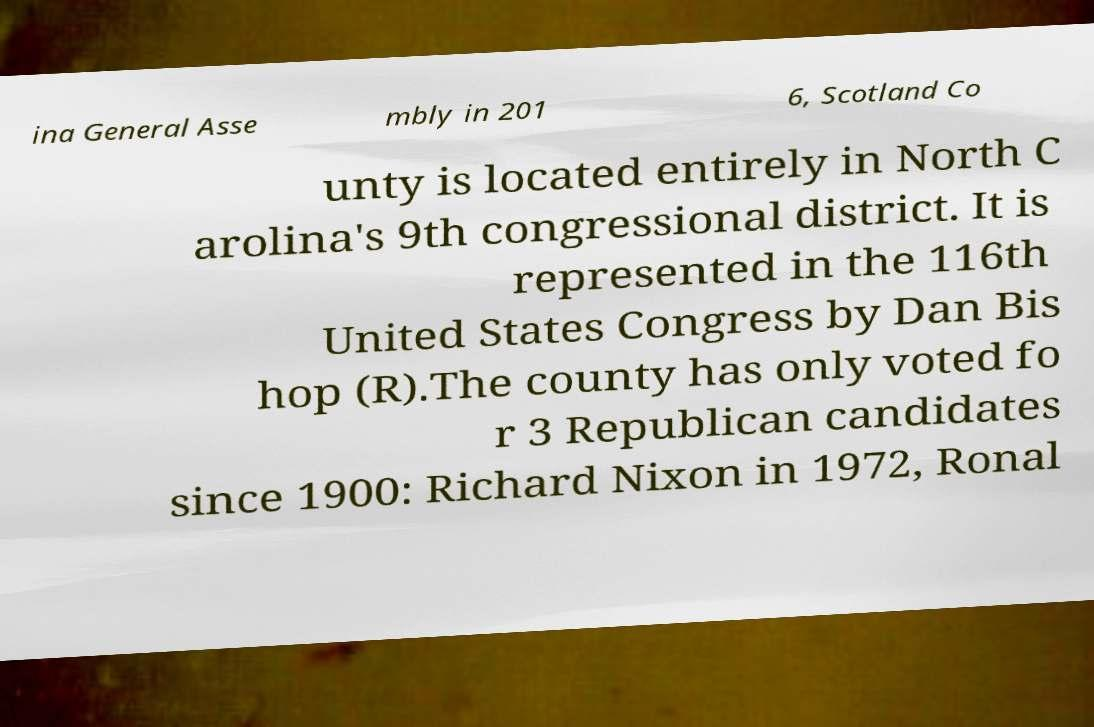Please read and relay the text visible in this image. What does it say? ina General Asse mbly in 201 6, Scotland Co unty is located entirely in North C arolina's 9th congressional district. It is represented in the 116th United States Congress by Dan Bis hop (R).The county has only voted fo r 3 Republican candidates since 1900: Richard Nixon in 1972, Ronal 